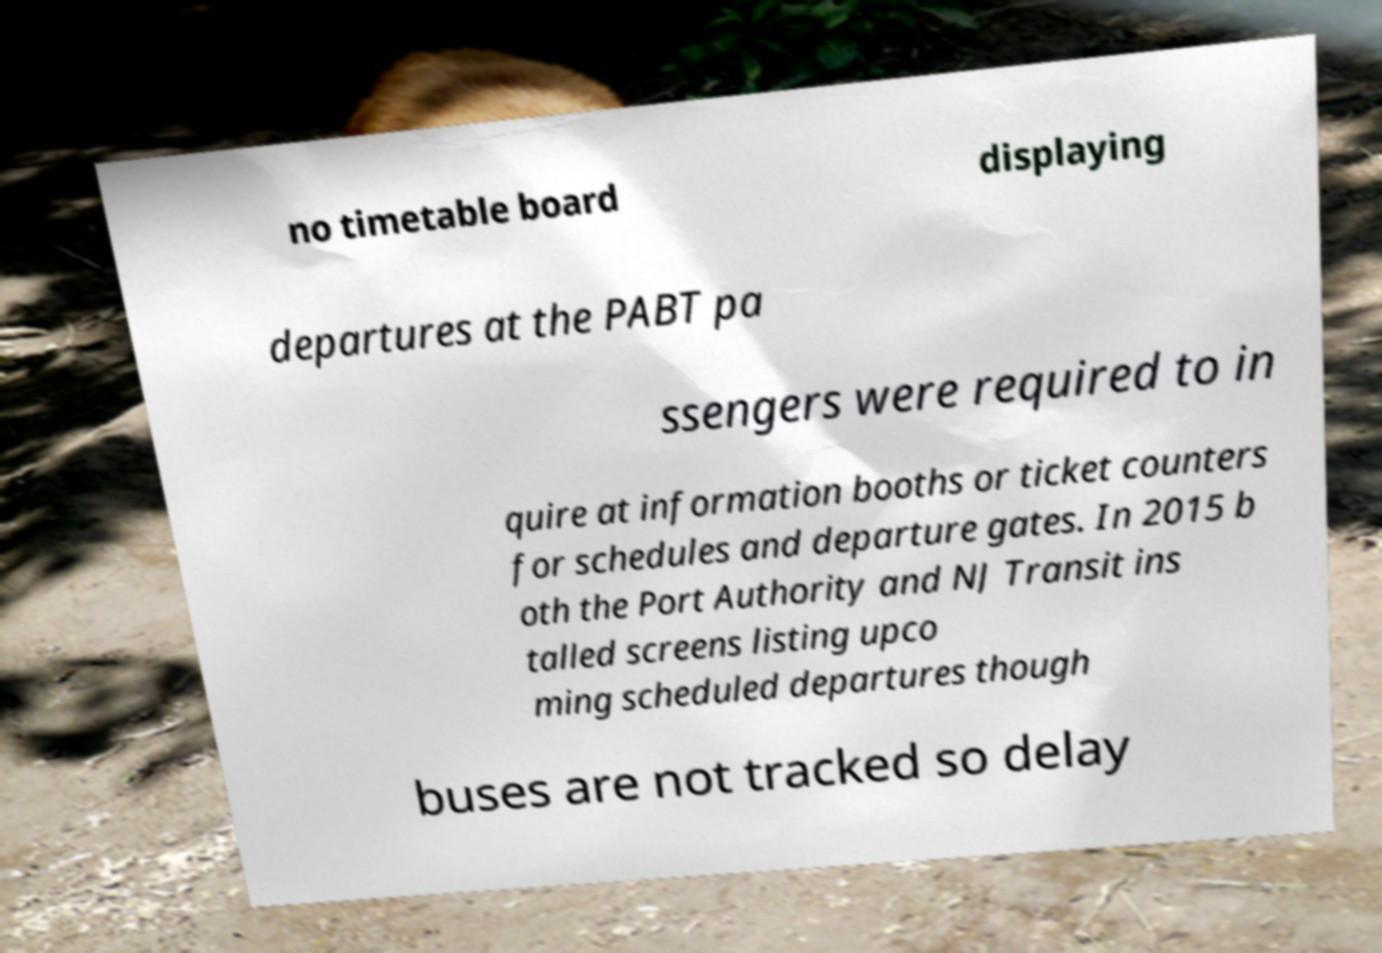Can you accurately transcribe the text from the provided image for me? no timetable board displaying departures at the PABT pa ssengers were required to in quire at information booths or ticket counters for schedules and departure gates. In 2015 b oth the Port Authority and NJ Transit ins talled screens listing upco ming scheduled departures though buses are not tracked so delay 